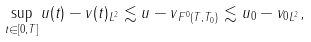<formula> <loc_0><loc_0><loc_500><loc_500>\sup _ { t \in [ 0 , T ] } \| u ( t ) - v ( t ) \| _ { L ^ { 2 } } \lesssim \| u - v \| _ { F ^ { 0 } ( T , T _ { 0 } ) } \lesssim \| u _ { 0 } - v _ { 0 } \| _ { L ^ { 2 } } ,</formula> 